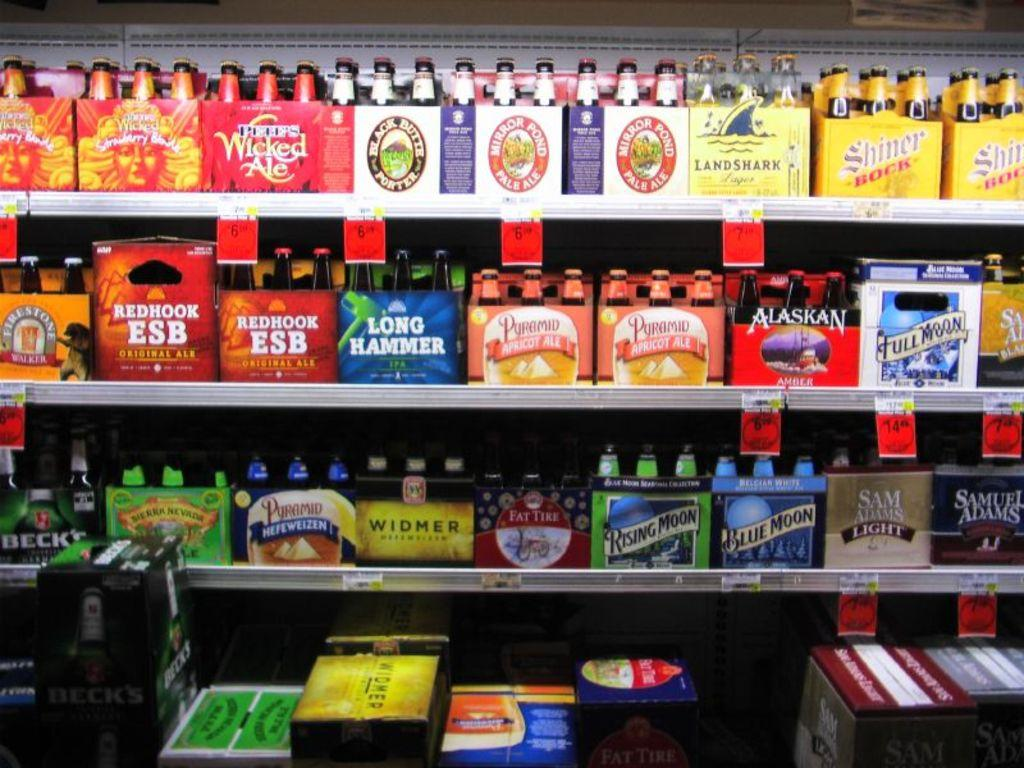<image>
Write a terse but informative summary of the picture. A lot of boxes of beer such as Blue Moon and Sam Adams are on the rack. 